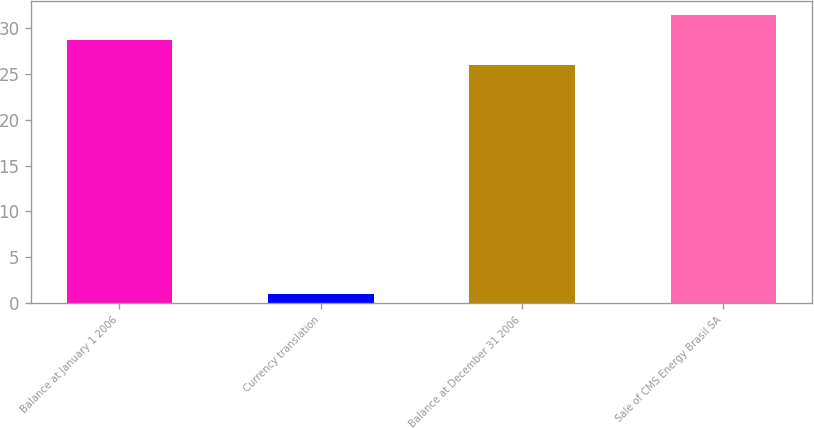Convert chart. <chart><loc_0><loc_0><loc_500><loc_500><bar_chart><fcel>Balance at January 1 2006<fcel>Currency translation<fcel>Balance at December 31 2006<fcel>Sale of CMS Energy Brasil SA<nl><fcel>28.7<fcel>1<fcel>26<fcel>31.4<nl></chart> 